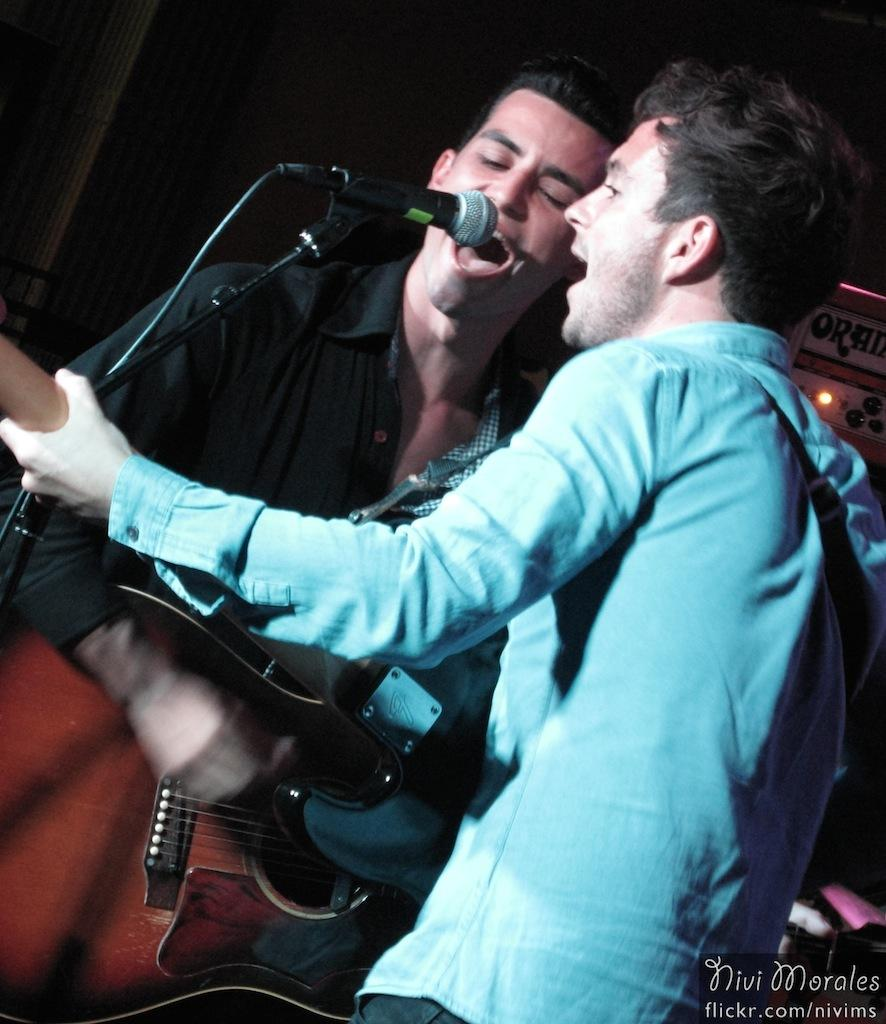How many people are in the image? There are persons in the image. What are the people wearing in the image? The persons are wearing blue and black shirts. What activity are the people engaged in? The persons are playing guitar and singing. What object is present in the image that is commonly used for amplifying sound? There is a microphone in the image. What type of weather can be seen in the image? The image does not depict any weather conditions; it focuses on the people and their activities. Is there a harbor visible in the image? There is no harbor present in the image. 